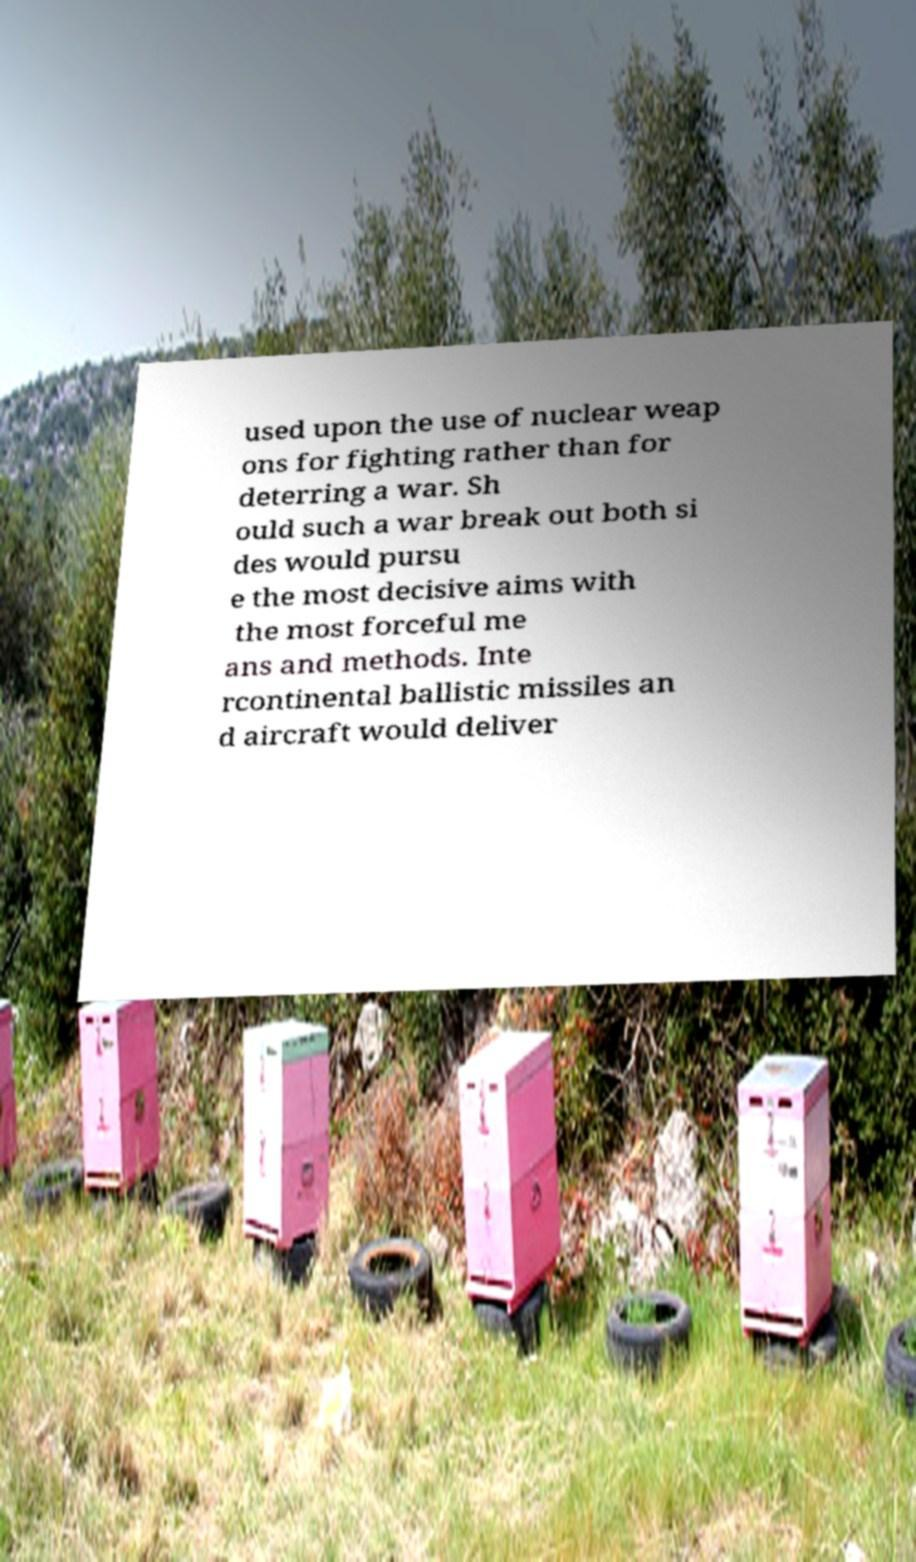I need the written content from this picture converted into text. Can you do that? used upon the use of nuclear weap ons for fighting rather than for deterring a war. Sh ould such a war break out both si des would pursu e the most decisive aims with the most forceful me ans and methods. Inte rcontinental ballistic missiles an d aircraft would deliver 